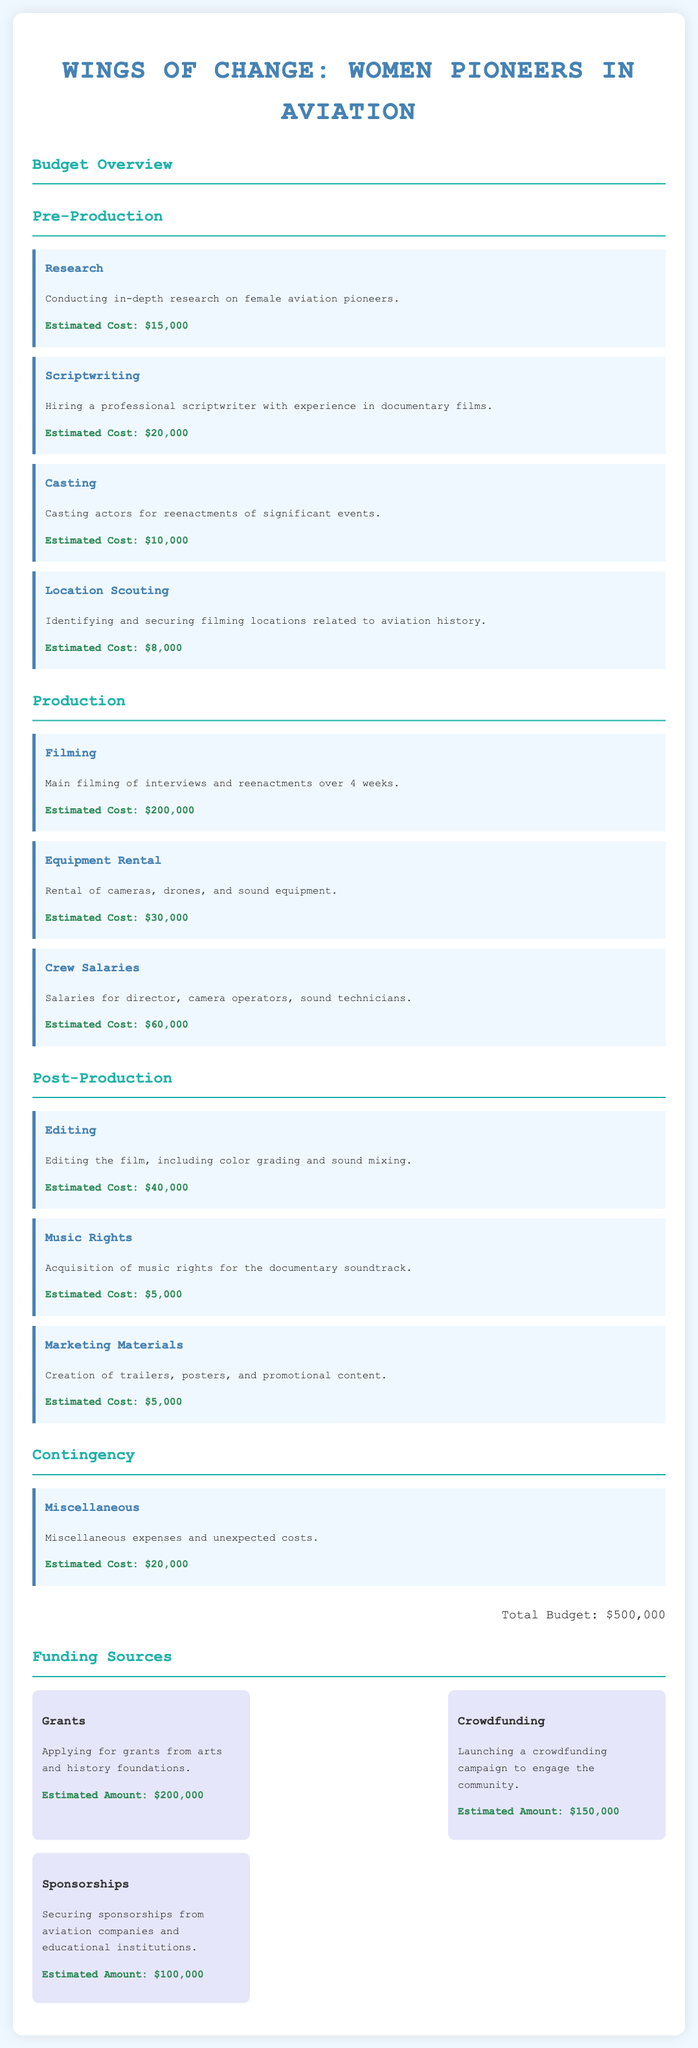What is the total budget for the documentary? The total budget is presented at the end of the budget overview.
Answer: $500,000 How much is allocated for research? The amount allocated for research is specified in the pre-production section.
Answer: $15,000 What is the estimated cost for equipment rental? This cost is mentioned under the production section for equipment rental.
Answer: $30,000 How many weeks is the filming scheduled for? The duration of the filming is provided in the description for filming in the production section.
Answer: 4 weeks What is the estimated cost for marketing materials? The document specifies the estimated cost for marketing materials in the post-production section.
Answer: $5,000 What are the three funding sources mentioned? The document lists several funding sources along with their estimated amounts.
Answer: Grants, Crowdfunding, Sponsorships What is the estimated amount from grants? The estimated funding from grants is detailed in the funding sources section of the document.
Answer: $200,000 Which area has the highest estimated cost? The areas are listed with their respective costs, and the highest one is identified.
Answer: Filming How much is budgeted for miscellaneous expenses? The miscellaneous expenses amount is provided in the contingency section of the budget overview.
Answer: $20,000 